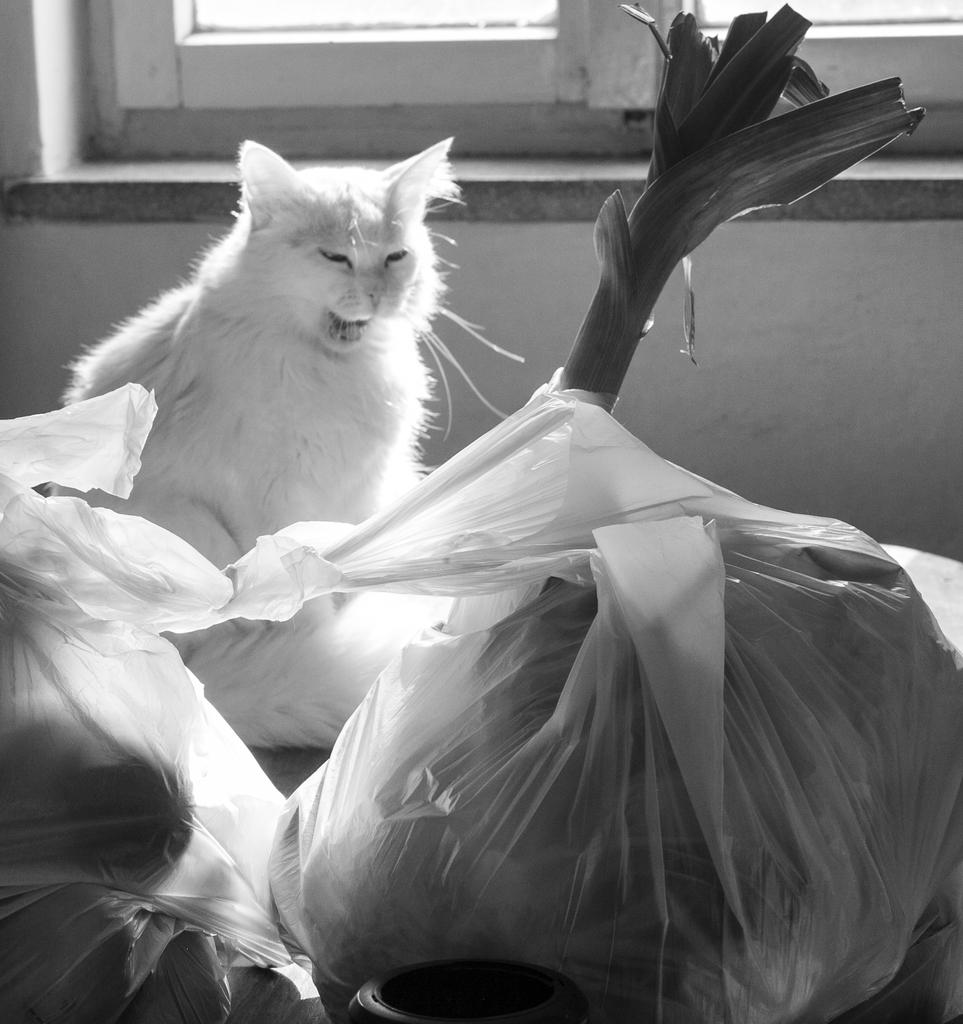What is the color scheme of the image? The image is black and white. What can be found inside the cover in the image? There are objects in a cover in the image. What type of vegetation is present in the image? There is a plant in the image. What animal is visible in the image? There is a cat in the image. What architectural feature can be seen in the image? There are windows in the image. What type of prose is being recited by the queen in the image? There is no queen or prose present in the image. What liquid is being poured by the cat in the image? There is no liquid or pouring action depicted in the image; the cat is simply visible. 